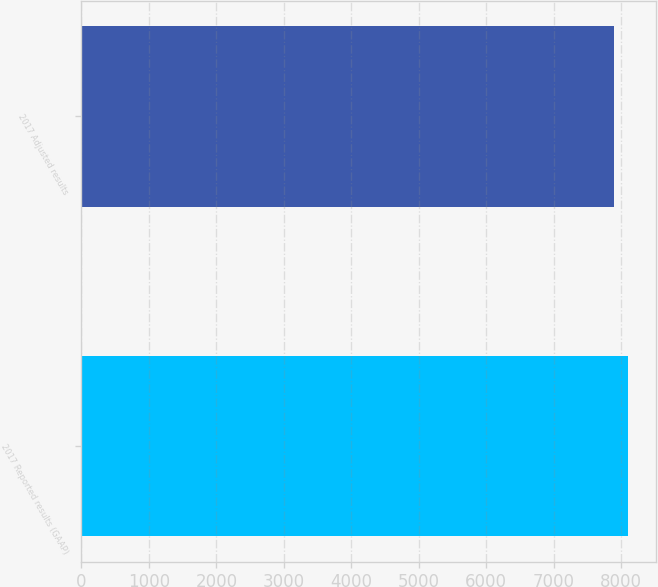Convert chart. <chart><loc_0><loc_0><loc_500><loc_500><bar_chart><fcel>2017 Reported results (GAAP)<fcel>2017 Adjusted results<nl><fcel>8106<fcel>7894<nl></chart> 